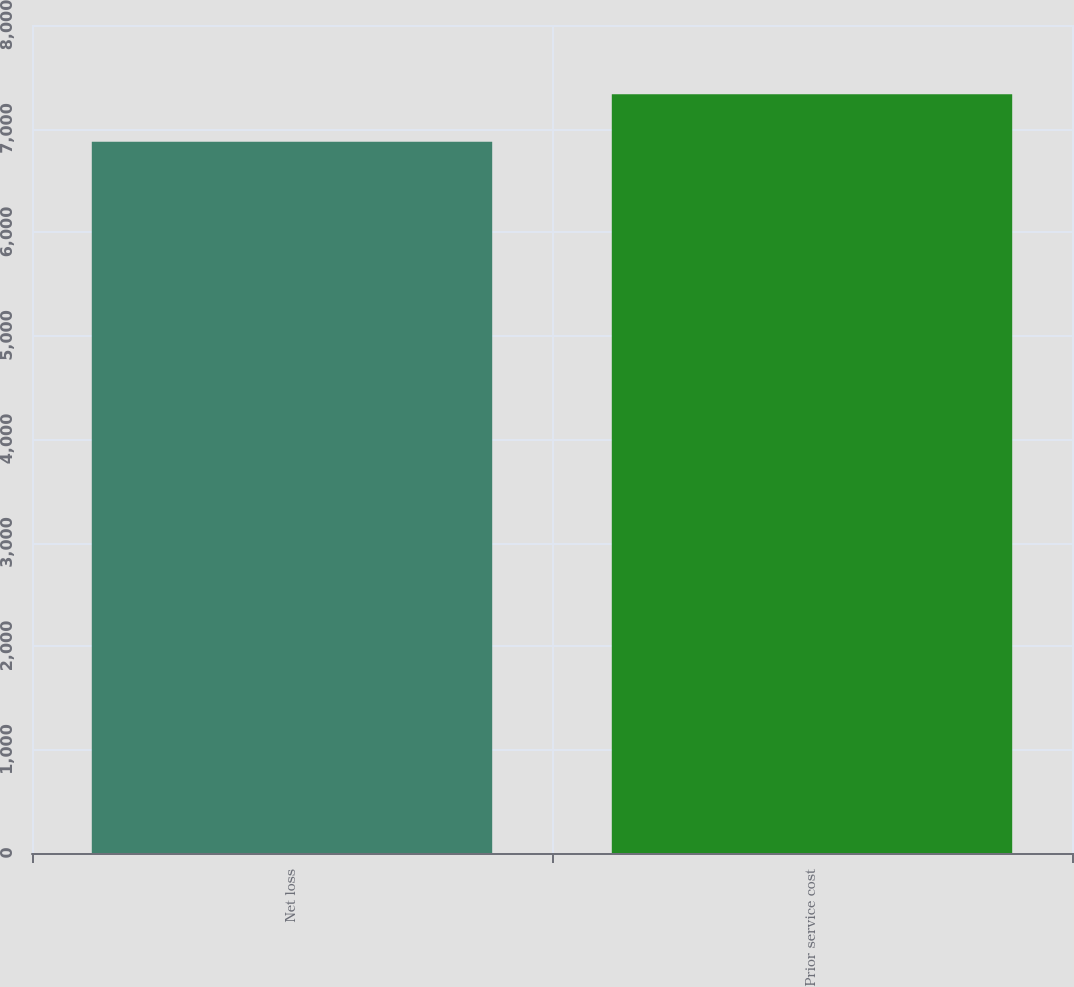Convert chart. <chart><loc_0><loc_0><loc_500><loc_500><bar_chart><fcel>Net loss<fcel>Prior service cost<nl><fcel>6872<fcel>7332<nl></chart> 